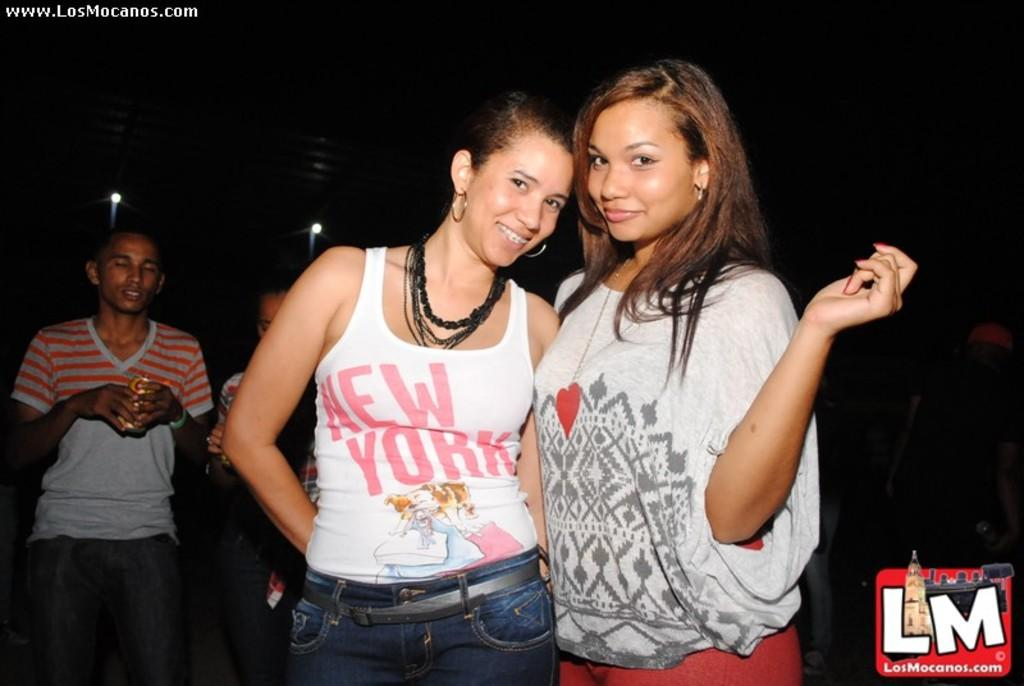How many women are in the image? There are two women in the image. What is the facial expression of the women? The women are smiling. What can be seen in the background of the image? There are lights and people visible in the background. How would you describe the lighting in the image? The background of the image is dark. Can you hear the women coughing in the image? There is no sound in the image, so it is not possible to hear the women coughing. 